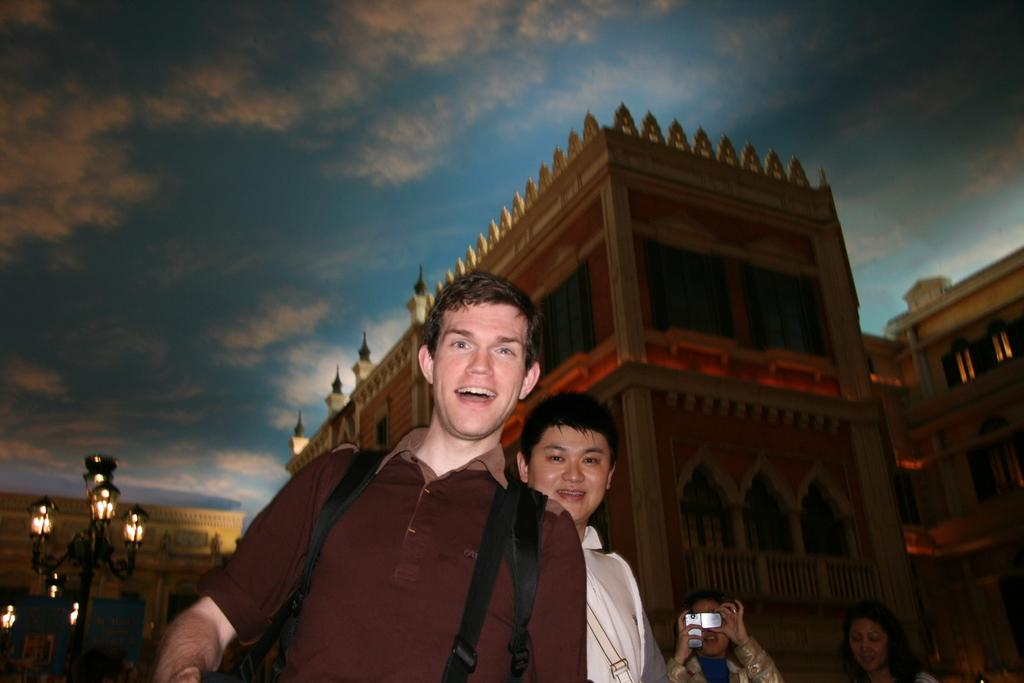What are the people in the image doing? The people in the image are standing and smiling. What can be seen in the background of the image? There is a fort in the background of the image. What is the pole with lights used for in the image? The pole with lights is likely used for illumination or decoration. What is the condition of the sky in the image? The sky is clear in the image. What type of pet can be seen playing with the people in the image? There is no pet present in the image; only people, a fort, a pole with lights, and a clear sky are visible. 